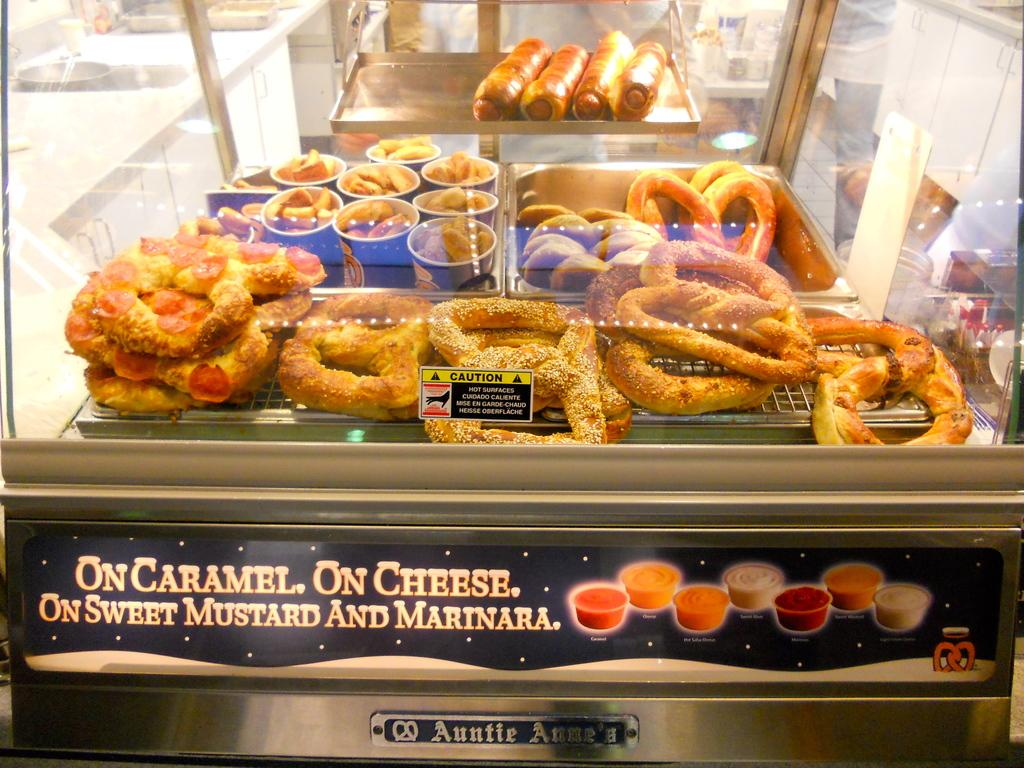What is inside the glass container in the image? There are donuts and rolls in the glass container. Can you describe the contents of the glass container in more detail? The glass container holds both donuts and rolls. What type of receipt can be seen in the image? There is no receipt present in the image. What is the cause of the argument between the donuts and rolls in the image? There is no argument between the donuts and rolls in the image, as they are inanimate objects. 